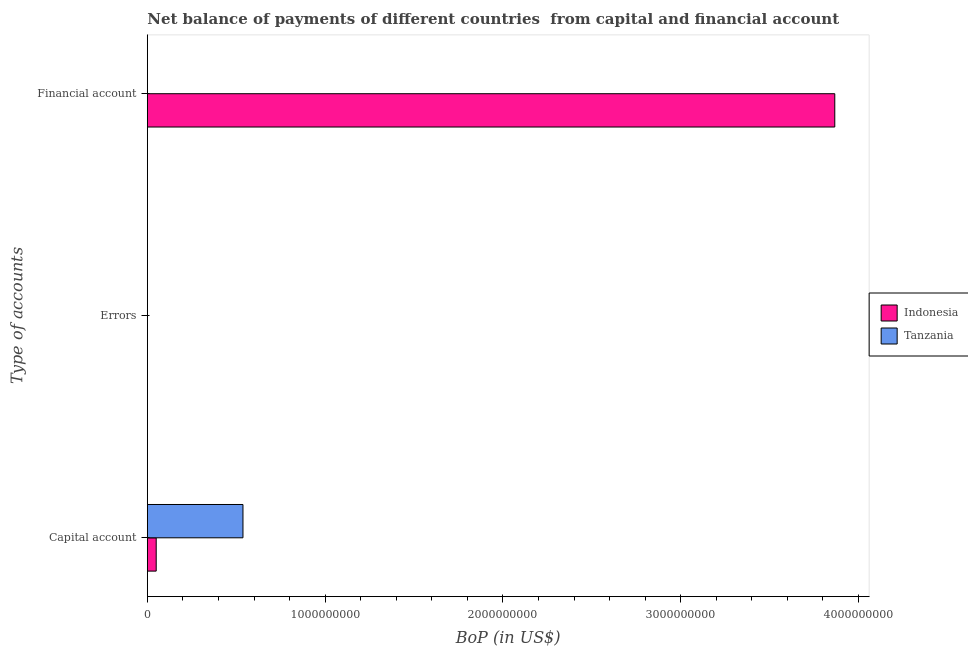Are the number of bars per tick equal to the number of legend labels?
Your answer should be compact. No. Are the number of bars on each tick of the Y-axis equal?
Your answer should be compact. No. How many bars are there on the 3rd tick from the top?
Your answer should be very brief. 2. What is the label of the 2nd group of bars from the top?
Keep it short and to the point. Errors. What is the amount of net capital account in Indonesia?
Give a very brief answer. 4.98e+07. Across all countries, what is the maximum amount of financial account?
Ensure brevity in your answer.  3.87e+09. Across all countries, what is the minimum amount of errors?
Provide a succinct answer. 0. In which country was the amount of net capital account maximum?
Your response must be concise. Tanzania. What is the difference between the amount of net capital account in Tanzania and that in Indonesia?
Your response must be concise. 4.88e+08. What is the difference between the amount of net capital account in Tanzania and the amount of errors in Indonesia?
Your response must be concise. 5.38e+08. What is the average amount of financial account per country?
Give a very brief answer. 1.93e+09. What is the difference between the amount of net capital account and amount of financial account in Indonesia?
Your answer should be very brief. -3.82e+09. What is the ratio of the amount of net capital account in Tanzania to that in Indonesia?
Ensure brevity in your answer.  10.79. What is the difference between the highest and the second highest amount of net capital account?
Make the answer very short. 4.88e+08. What is the difference between the highest and the lowest amount of net capital account?
Your answer should be compact. 4.88e+08. In how many countries, is the amount of net capital account greater than the average amount of net capital account taken over all countries?
Offer a terse response. 1. Is the sum of the amount of net capital account in Indonesia and Tanzania greater than the maximum amount of errors across all countries?
Offer a terse response. Yes. Is it the case that in every country, the sum of the amount of net capital account and amount of errors is greater than the amount of financial account?
Your response must be concise. No. How many countries are there in the graph?
Ensure brevity in your answer.  2. What is the difference between two consecutive major ticks on the X-axis?
Your answer should be very brief. 1.00e+09. Are the values on the major ticks of X-axis written in scientific E-notation?
Offer a very short reply. No. Does the graph contain grids?
Provide a succinct answer. No. How many legend labels are there?
Offer a terse response. 2. How are the legend labels stacked?
Your response must be concise. Vertical. What is the title of the graph?
Give a very brief answer. Net balance of payments of different countries  from capital and financial account. What is the label or title of the X-axis?
Give a very brief answer. BoP (in US$). What is the label or title of the Y-axis?
Keep it short and to the point. Type of accounts. What is the BoP (in US$) in Indonesia in Capital account?
Make the answer very short. 4.98e+07. What is the BoP (in US$) of Tanzania in Capital account?
Give a very brief answer. 5.38e+08. What is the BoP (in US$) in Indonesia in Errors?
Make the answer very short. 0. What is the BoP (in US$) in Tanzania in Errors?
Offer a very short reply. 0. What is the BoP (in US$) in Indonesia in Financial account?
Keep it short and to the point. 3.87e+09. What is the BoP (in US$) of Tanzania in Financial account?
Offer a very short reply. 0. Across all Type of accounts, what is the maximum BoP (in US$) in Indonesia?
Your response must be concise. 3.87e+09. Across all Type of accounts, what is the maximum BoP (in US$) in Tanzania?
Make the answer very short. 5.38e+08. Across all Type of accounts, what is the minimum BoP (in US$) of Indonesia?
Provide a short and direct response. 0. What is the total BoP (in US$) of Indonesia in the graph?
Keep it short and to the point. 3.92e+09. What is the total BoP (in US$) in Tanzania in the graph?
Provide a succinct answer. 5.38e+08. What is the difference between the BoP (in US$) of Indonesia in Capital account and that in Financial account?
Provide a short and direct response. -3.82e+09. What is the average BoP (in US$) in Indonesia per Type of accounts?
Offer a very short reply. 1.31e+09. What is the average BoP (in US$) in Tanzania per Type of accounts?
Your answer should be compact. 1.79e+08. What is the difference between the BoP (in US$) in Indonesia and BoP (in US$) in Tanzania in Capital account?
Your answer should be very brief. -4.88e+08. What is the ratio of the BoP (in US$) in Indonesia in Capital account to that in Financial account?
Your response must be concise. 0.01. What is the difference between the highest and the lowest BoP (in US$) in Indonesia?
Offer a very short reply. 3.87e+09. What is the difference between the highest and the lowest BoP (in US$) of Tanzania?
Your response must be concise. 5.38e+08. 